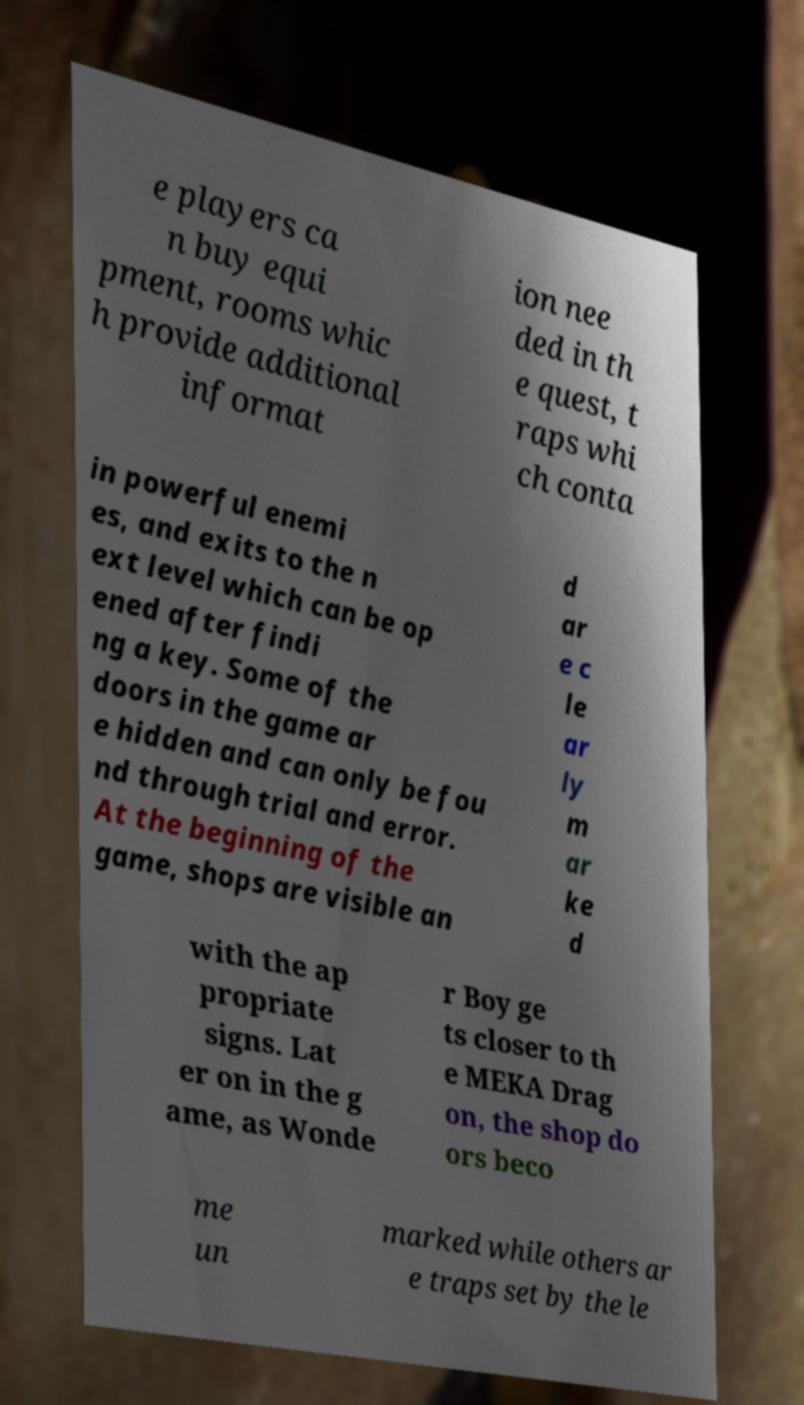What messages or text are displayed in this image? I need them in a readable, typed format. e players ca n buy equi pment, rooms whic h provide additional informat ion nee ded in th e quest, t raps whi ch conta in powerful enemi es, and exits to the n ext level which can be op ened after findi ng a key. Some of the doors in the game ar e hidden and can only be fou nd through trial and error. At the beginning of the game, shops are visible an d ar e c le ar ly m ar ke d with the ap propriate signs. Lat er on in the g ame, as Wonde r Boy ge ts closer to th e MEKA Drag on, the shop do ors beco me un marked while others ar e traps set by the le 